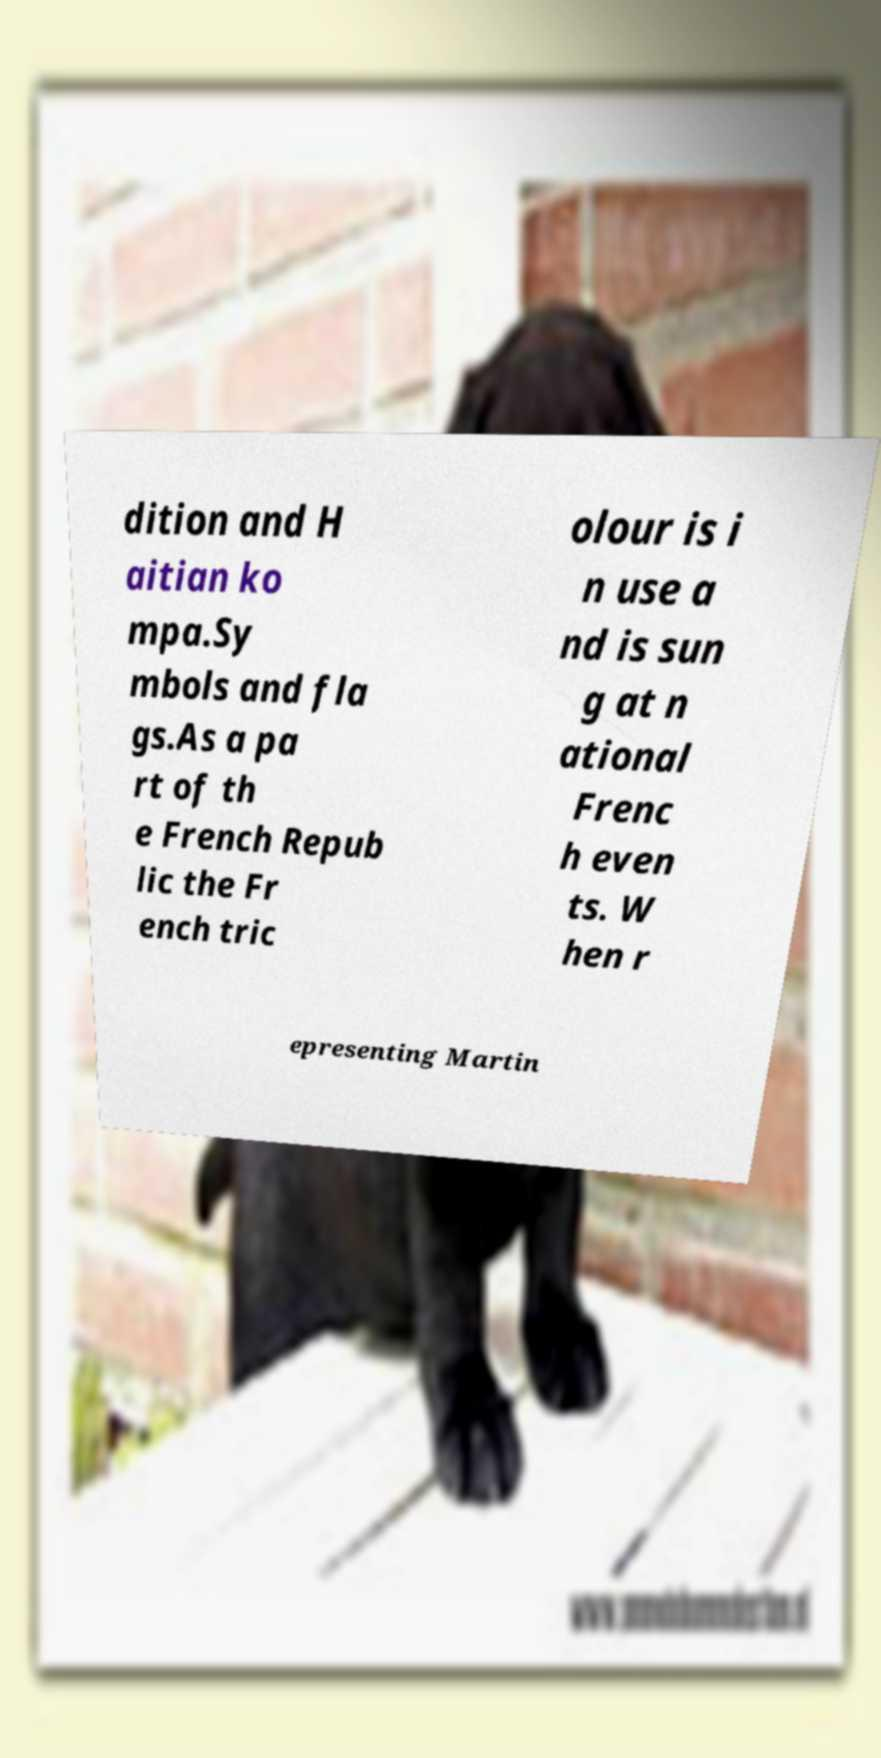Please identify and transcribe the text found in this image. dition and H aitian ko mpa.Sy mbols and fla gs.As a pa rt of th e French Repub lic the Fr ench tric olour is i n use a nd is sun g at n ational Frenc h even ts. W hen r epresenting Martin 